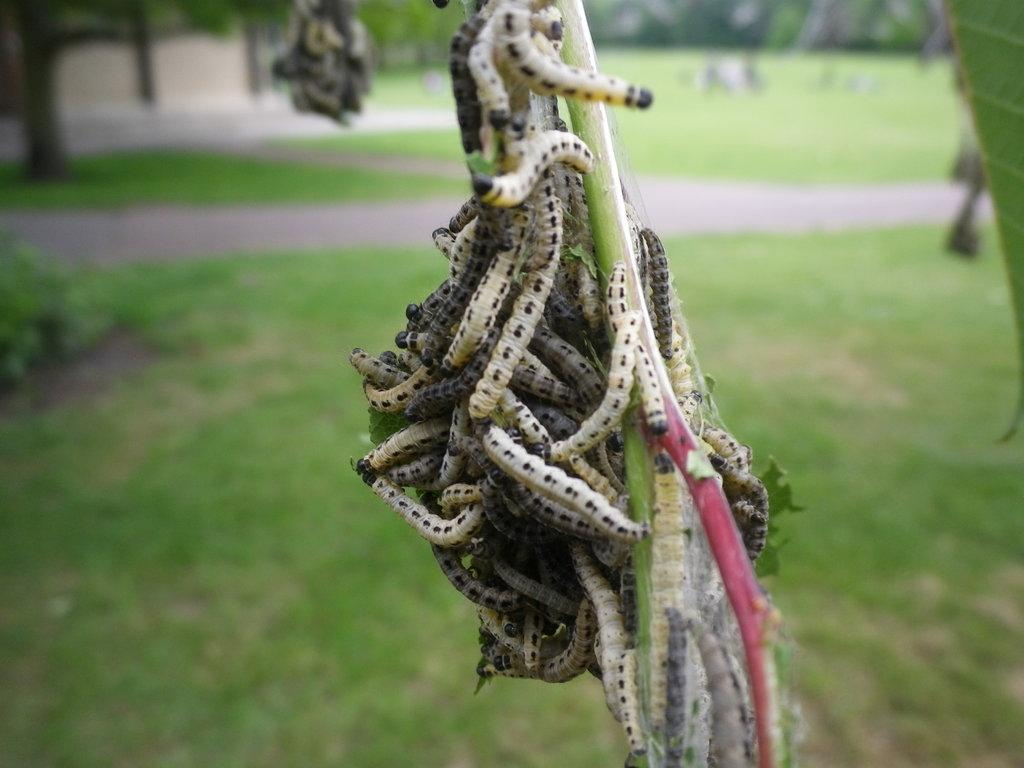What type of organisms can be seen on the stem in the image? There are worms on a stem in the image. What type of vegetation is visible in the background of the image? There is grass visible in the background of the image. What other natural elements can be seen in the background of the image? There are trees in the background of the image. What type of jewel is being used for arithmetic calculations in the image? There is no jewel or arithmetic calculations present in the image. 